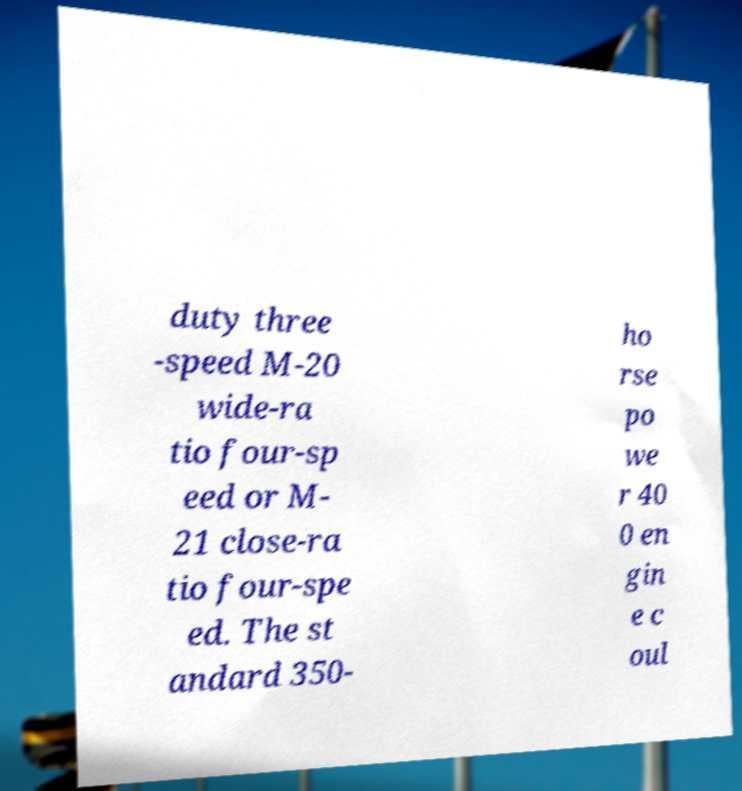There's text embedded in this image that I need extracted. Can you transcribe it verbatim? duty three -speed M-20 wide-ra tio four-sp eed or M- 21 close-ra tio four-spe ed. The st andard 350- ho rse po we r 40 0 en gin e c oul 